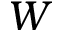Convert formula to latex. <formula><loc_0><loc_0><loc_500><loc_500>W</formula> 